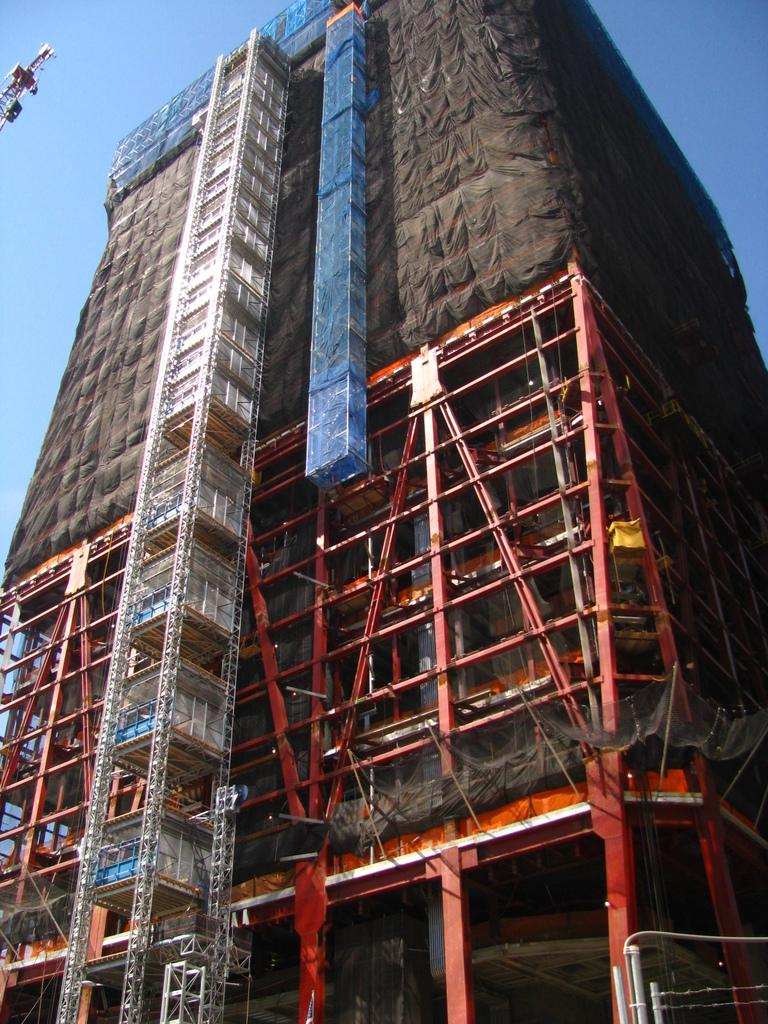What is the main subject in the center of the image? There is a building in the center of the image. What type of structures can be seen in the image? There are iron poles in the image. What is visible at the top of the image? The sky is visible at the top of the image. What type of dinner is being served in the image? There is no dinner present in the image. How much debt is visible in the image? There is no debt visible in the image. 